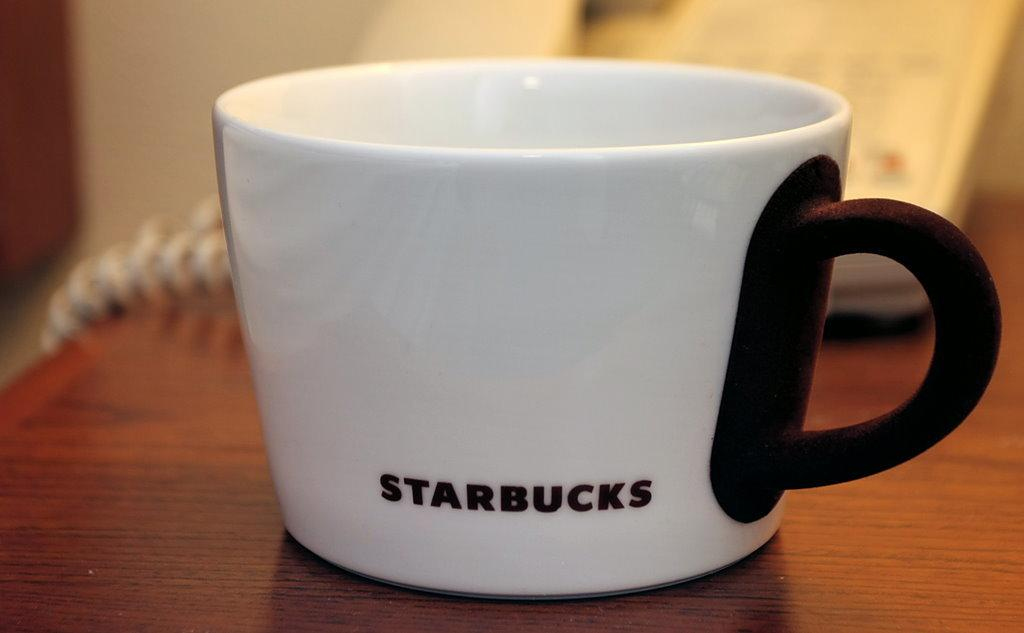<image>
Write a terse but informative summary of the picture. a white starbucks mug with a black handle on a wooden table 